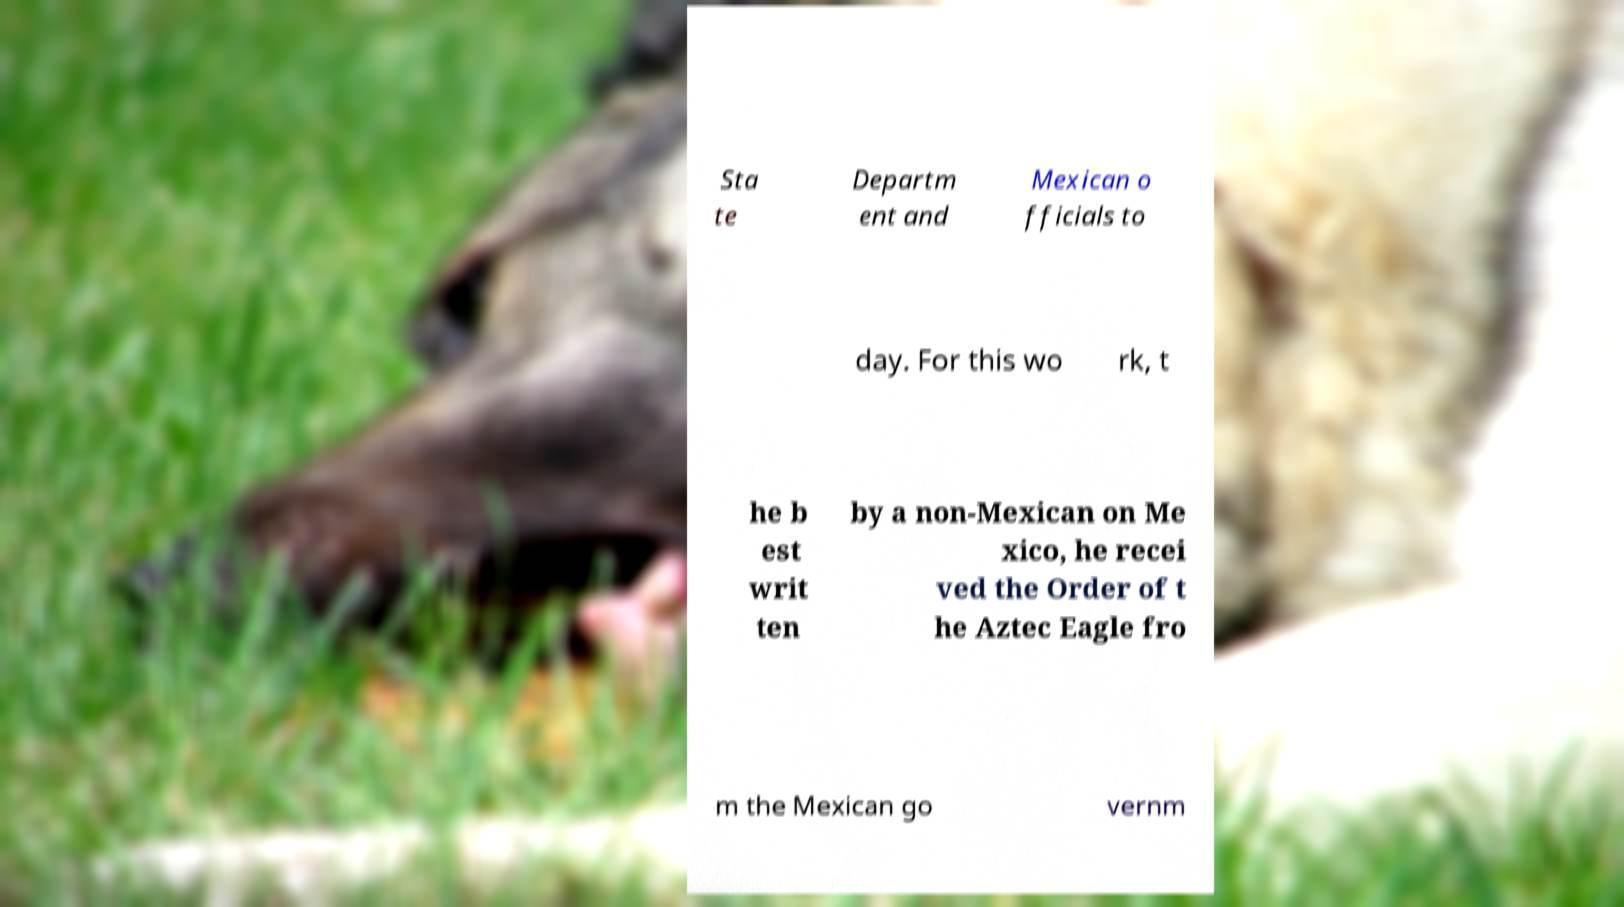Please read and relay the text visible in this image. What does it say? Sta te Departm ent and Mexican o fficials to day. For this wo rk, t he b est writ ten by a non-Mexican on Me xico, he recei ved the Order of t he Aztec Eagle fro m the Mexican go vernm 